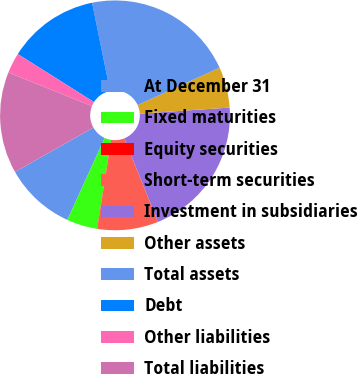<chart> <loc_0><loc_0><loc_500><loc_500><pie_chart><fcel>At December 31<fcel>Fixed maturities<fcel>Equity securities<fcel>Short-term securities<fcel>Investment in subsidiaries<fcel>Other assets<fcel>Total assets<fcel>Debt<fcel>Other liabilities<fcel>Total liabilities<nl><fcel>10.0%<fcel>4.3%<fcel>0.03%<fcel>8.58%<fcel>19.97%<fcel>5.73%<fcel>21.39%<fcel>12.85%<fcel>2.88%<fcel>14.27%<nl></chart> 